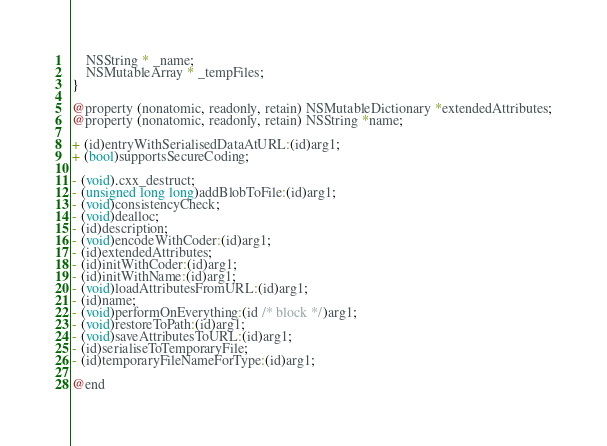<code> <loc_0><loc_0><loc_500><loc_500><_C_>    NSString * _name;
    NSMutableArray * _tempFiles;
}

@property (nonatomic, readonly, retain) NSMutableDictionary *extendedAttributes;
@property (nonatomic, readonly, retain) NSString *name;

+ (id)entryWithSerialisedDataAtURL:(id)arg1;
+ (bool)supportsSecureCoding;

- (void).cxx_destruct;
- (unsigned long long)addBlobToFile:(id)arg1;
- (void)consistencyCheck;
- (void)dealloc;
- (id)description;
- (void)encodeWithCoder:(id)arg1;
- (id)extendedAttributes;
- (id)initWithCoder:(id)arg1;
- (id)initWithName:(id)arg1;
- (void)loadAttributesFromURL:(id)arg1;
- (id)name;
- (void)performOnEverything:(id /* block */)arg1;
- (void)restoreToPath:(id)arg1;
- (void)saveAttributesToURL:(id)arg1;
- (id)serialiseToTemporaryFile;
- (id)temporaryFileNameForType:(id)arg1;

@end
</code> 